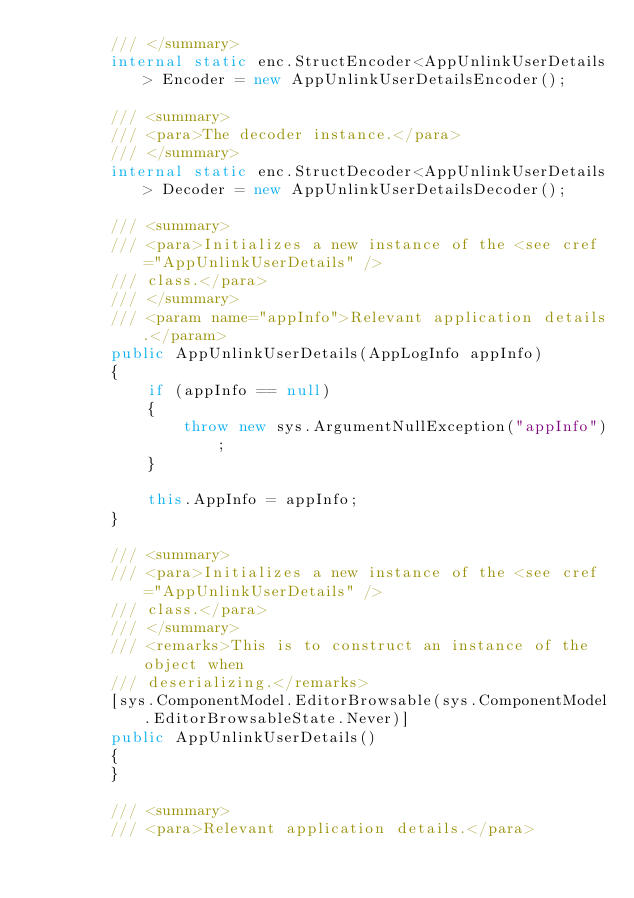<code> <loc_0><loc_0><loc_500><loc_500><_C#_>        /// </summary>
        internal static enc.StructEncoder<AppUnlinkUserDetails> Encoder = new AppUnlinkUserDetailsEncoder();

        /// <summary>
        /// <para>The decoder instance.</para>
        /// </summary>
        internal static enc.StructDecoder<AppUnlinkUserDetails> Decoder = new AppUnlinkUserDetailsDecoder();

        /// <summary>
        /// <para>Initializes a new instance of the <see cref="AppUnlinkUserDetails" />
        /// class.</para>
        /// </summary>
        /// <param name="appInfo">Relevant application details.</param>
        public AppUnlinkUserDetails(AppLogInfo appInfo)
        {
            if (appInfo == null)
            {
                throw new sys.ArgumentNullException("appInfo");
            }

            this.AppInfo = appInfo;
        }

        /// <summary>
        /// <para>Initializes a new instance of the <see cref="AppUnlinkUserDetails" />
        /// class.</para>
        /// </summary>
        /// <remarks>This is to construct an instance of the object when
        /// deserializing.</remarks>
        [sys.ComponentModel.EditorBrowsable(sys.ComponentModel.EditorBrowsableState.Never)]
        public AppUnlinkUserDetails()
        {
        }

        /// <summary>
        /// <para>Relevant application details.</para></code> 